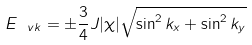Convert formula to latex. <formula><loc_0><loc_0><loc_500><loc_500>E _ { \ v k } = \pm \frac { 3 } { 4 } J | \chi | \sqrt { \sin ^ { 2 } k _ { x } + \sin ^ { 2 } k _ { y } }</formula> 